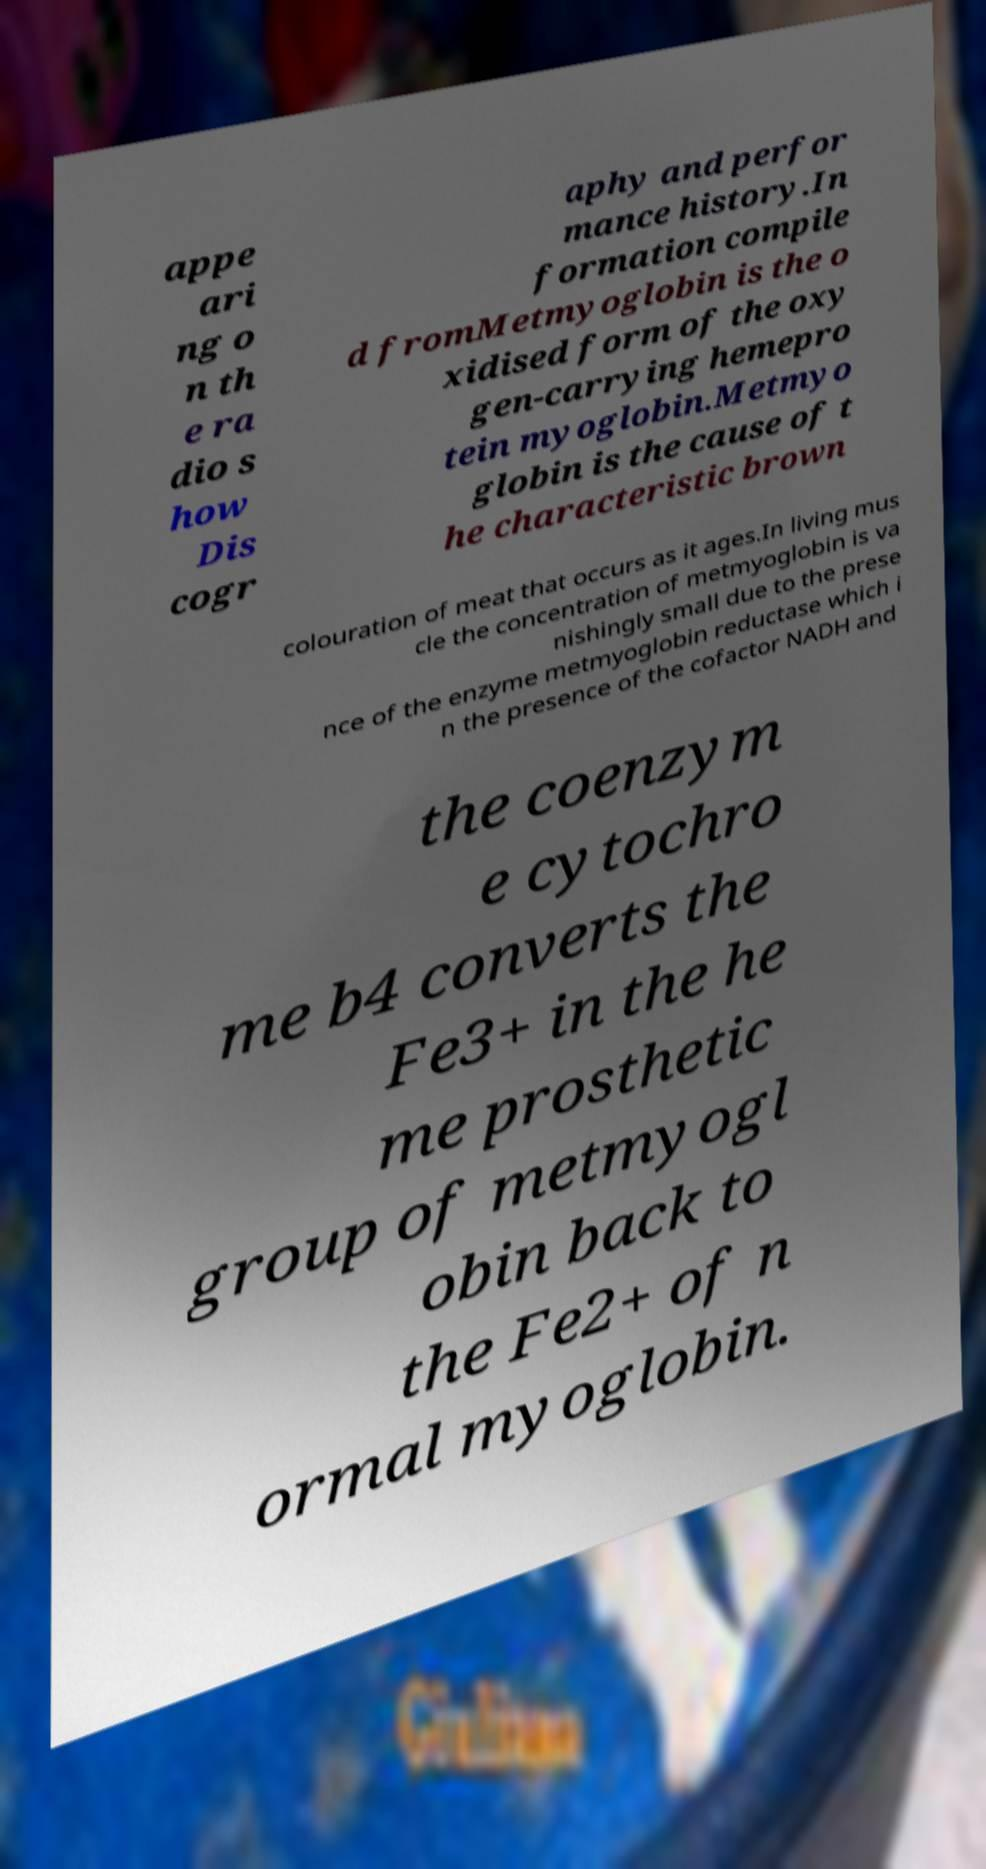Could you assist in decoding the text presented in this image and type it out clearly? appe ari ng o n th e ra dio s how Dis cogr aphy and perfor mance history.In formation compile d fromMetmyoglobin is the o xidised form of the oxy gen-carrying hemepro tein myoglobin.Metmyo globin is the cause of t he characteristic brown colouration of meat that occurs as it ages.In living mus cle the concentration of metmyoglobin is va nishingly small due to the prese nce of the enzyme metmyoglobin reductase which i n the presence of the cofactor NADH and the coenzym e cytochro me b4 converts the Fe3+ in the he me prosthetic group of metmyogl obin back to the Fe2+ of n ormal myoglobin. 